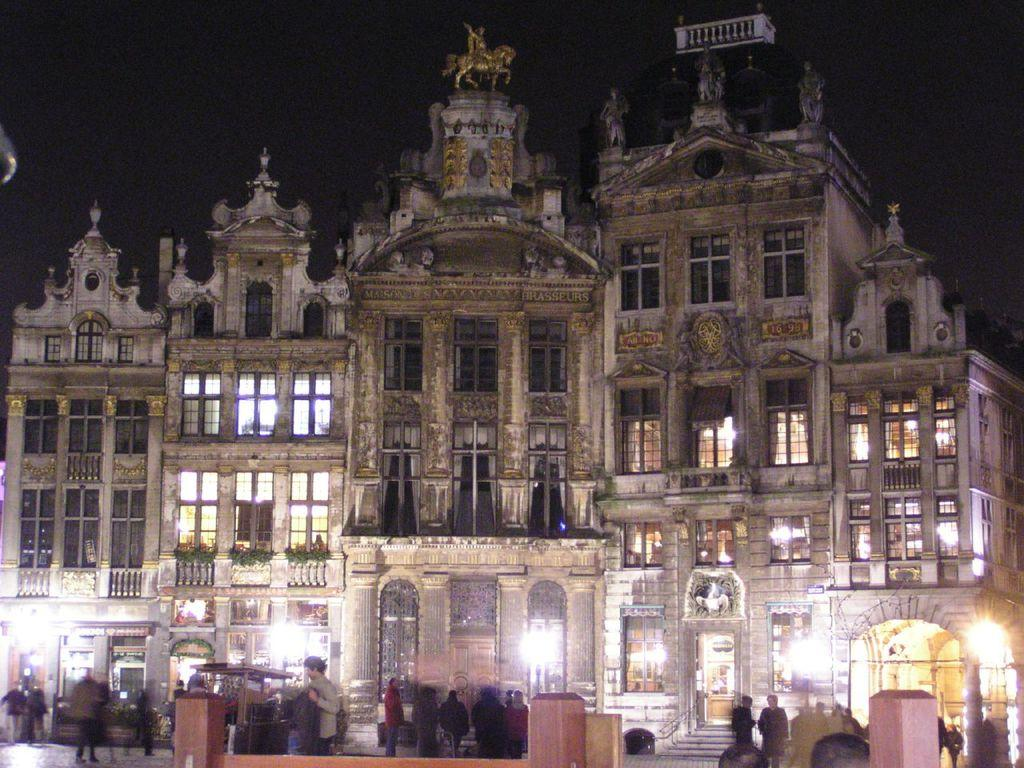What is the main structure in the image? There is a building in the image. What feature can be seen on the building? The building has windows. Are there any people visible in the image? Yes, there are people in front of the building. What type of songs are being sung by the people in front of the building? There is no indication in the image that the people are singing songs, so it cannot be determined from the picture. 